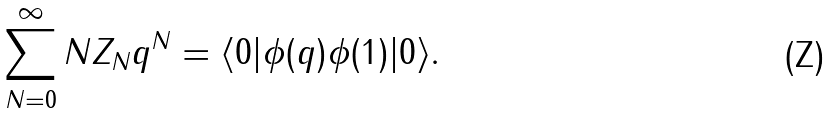Convert formula to latex. <formula><loc_0><loc_0><loc_500><loc_500>\sum _ { N = 0 } ^ { \infty } N Z _ { N } q ^ { N } = \langle 0 | \phi ( q ) \phi ( 1 ) | 0 \rangle .</formula> 